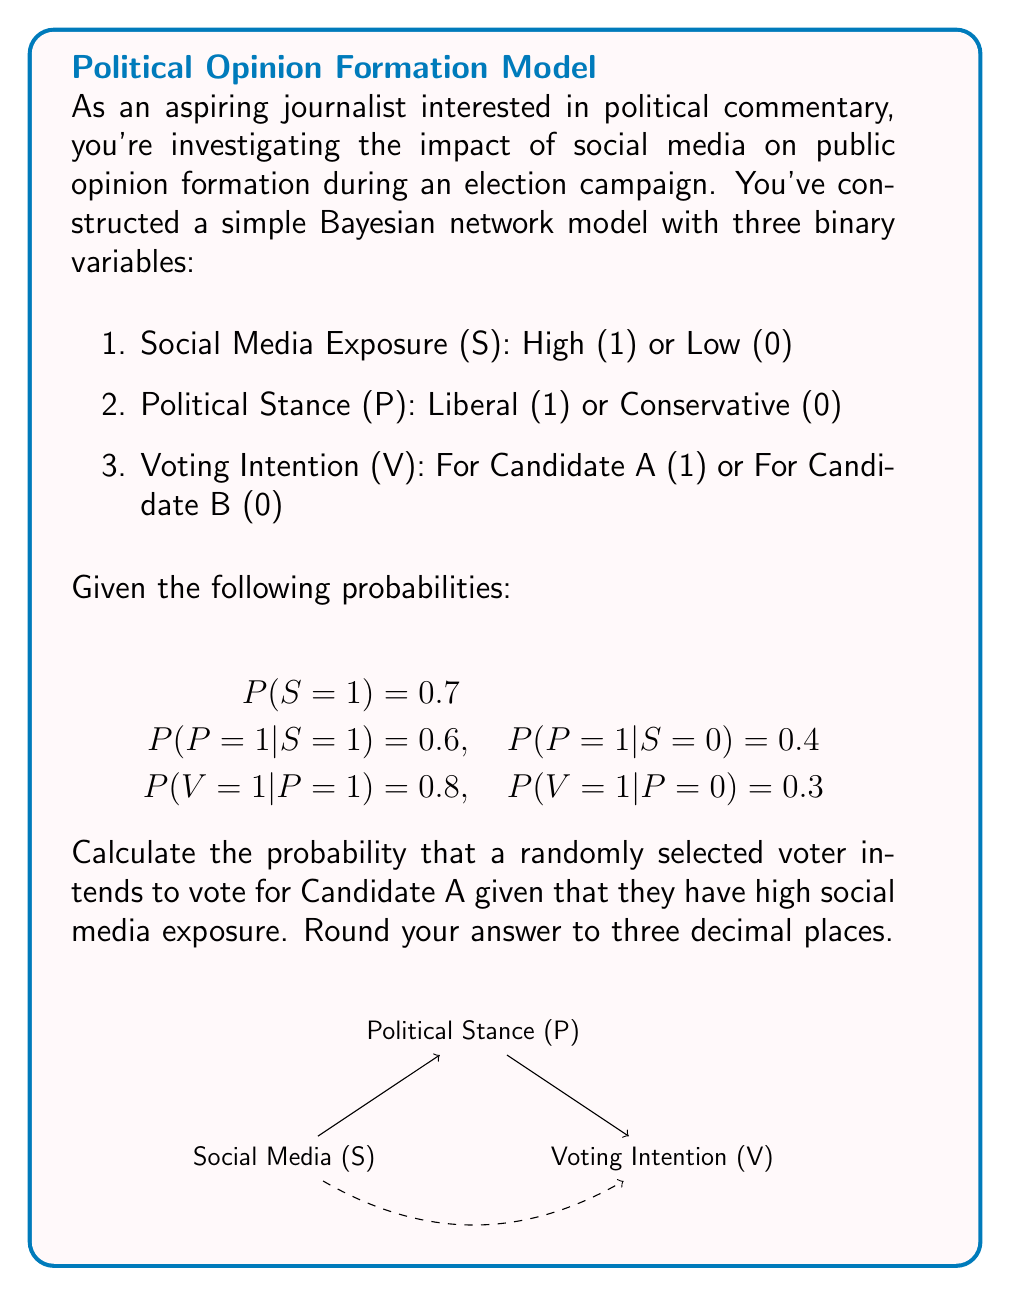Could you help me with this problem? Let's approach this step-by-step using Bayes' theorem and the law of total probability:

1) We need to calculate $P(V=1|S=1)$.

2) Using the law of total probability:

   $$P(V=1|S=1) = P(V=1|P=1,S=1)P(P=1|S=1) + P(V=1|P=0,S=1)P(P=0|S=1)$$

3) From the given information:
   $P(P=1|S=1) = 0.6$
   $P(P=0|S=1) = 1 - 0.6 = 0.4$
   $P(V=1|P=1) = 0.8$
   $P(V=1|P=0) = 0.3$

4) Note that $P(V=1|P=1,S=1) = P(V=1|P=1)$ and $P(V=1|P=0,S=1) = P(V=1|P=0)$ due to the conditional independence assumptions in the Bayesian network.

5) Substituting these values:

   $$P(V=1|S=1) = (0.8)(0.6) + (0.3)(0.4)$$

6) Calculating:
   $$P(V=1|S=1) = 0.48 + 0.12 = 0.60$$

7) Rounding to three decimal places: 0.600
Answer: 0.600 